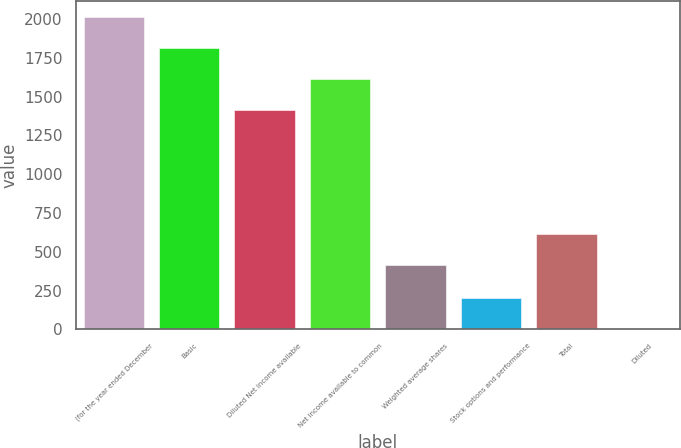<chart> <loc_0><loc_0><loc_500><loc_500><bar_chart><fcel>(for the year ended December<fcel>Basic<fcel>Diluted Net income available<fcel>Net income available to common<fcel>Weighted average shares<fcel>Stock options and performance<fcel>Total<fcel>Diluted<nl><fcel>2016.28<fcel>1815.52<fcel>1414<fcel>1614.76<fcel>415.8<fcel>204.12<fcel>616.56<fcel>3.36<nl></chart> 